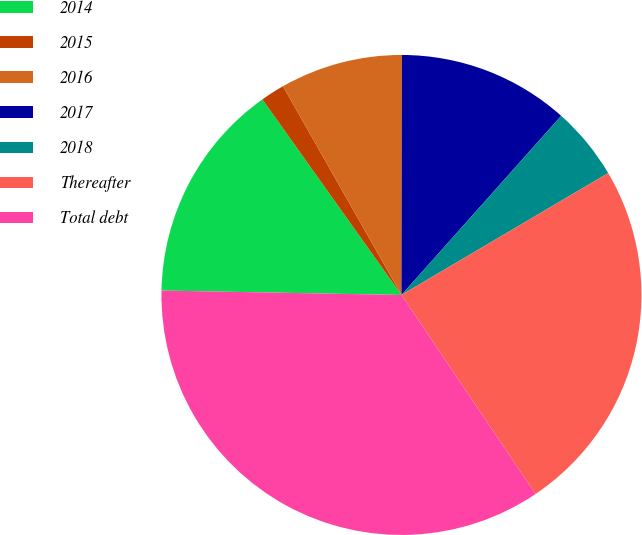Convert chart. <chart><loc_0><loc_0><loc_500><loc_500><pie_chart><fcel>2014<fcel>2015<fcel>2016<fcel>2017<fcel>2018<fcel>Thereafter<fcel>Total debt<nl><fcel>14.87%<fcel>1.62%<fcel>8.25%<fcel>11.56%<fcel>4.93%<fcel>24.05%<fcel>34.73%<nl></chart> 